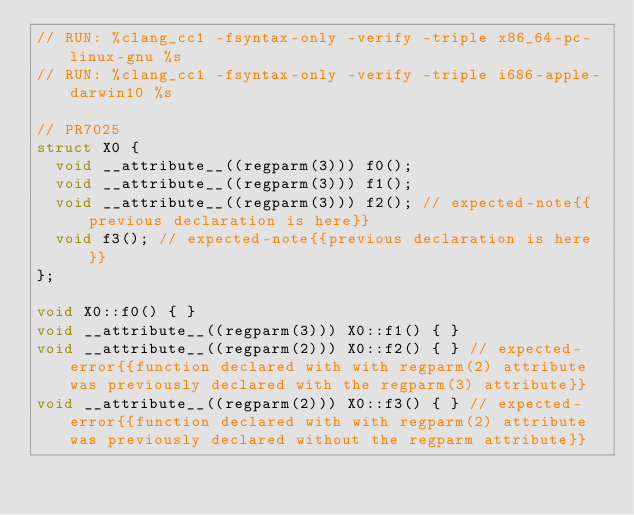Convert code to text. <code><loc_0><loc_0><loc_500><loc_500><_C++_>// RUN: %clang_cc1 -fsyntax-only -verify -triple x86_64-pc-linux-gnu %s
// RUN: %clang_cc1 -fsyntax-only -verify -triple i686-apple-darwin10 %s

// PR7025
struct X0 {
  void __attribute__((regparm(3))) f0();
  void __attribute__((regparm(3))) f1();
  void __attribute__((regparm(3))) f2(); // expected-note{{previous declaration is here}}
  void f3(); // expected-note{{previous declaration is here}}
};

void X0::f0() { }
void __attribute__((regparm(3))) X0::f1() { }
void __attribute__((regparm(2))) X0::f2() { } // expected-error{{function declared with with regparm(2) attribute was previously declared with the regparm(3) attribute}}
void __attribute__((regparm(2))) X0::f3() { } // expected-error{{function declared with with regparm(2) attribute was previously declared without the regparm attribute}}
</code> 